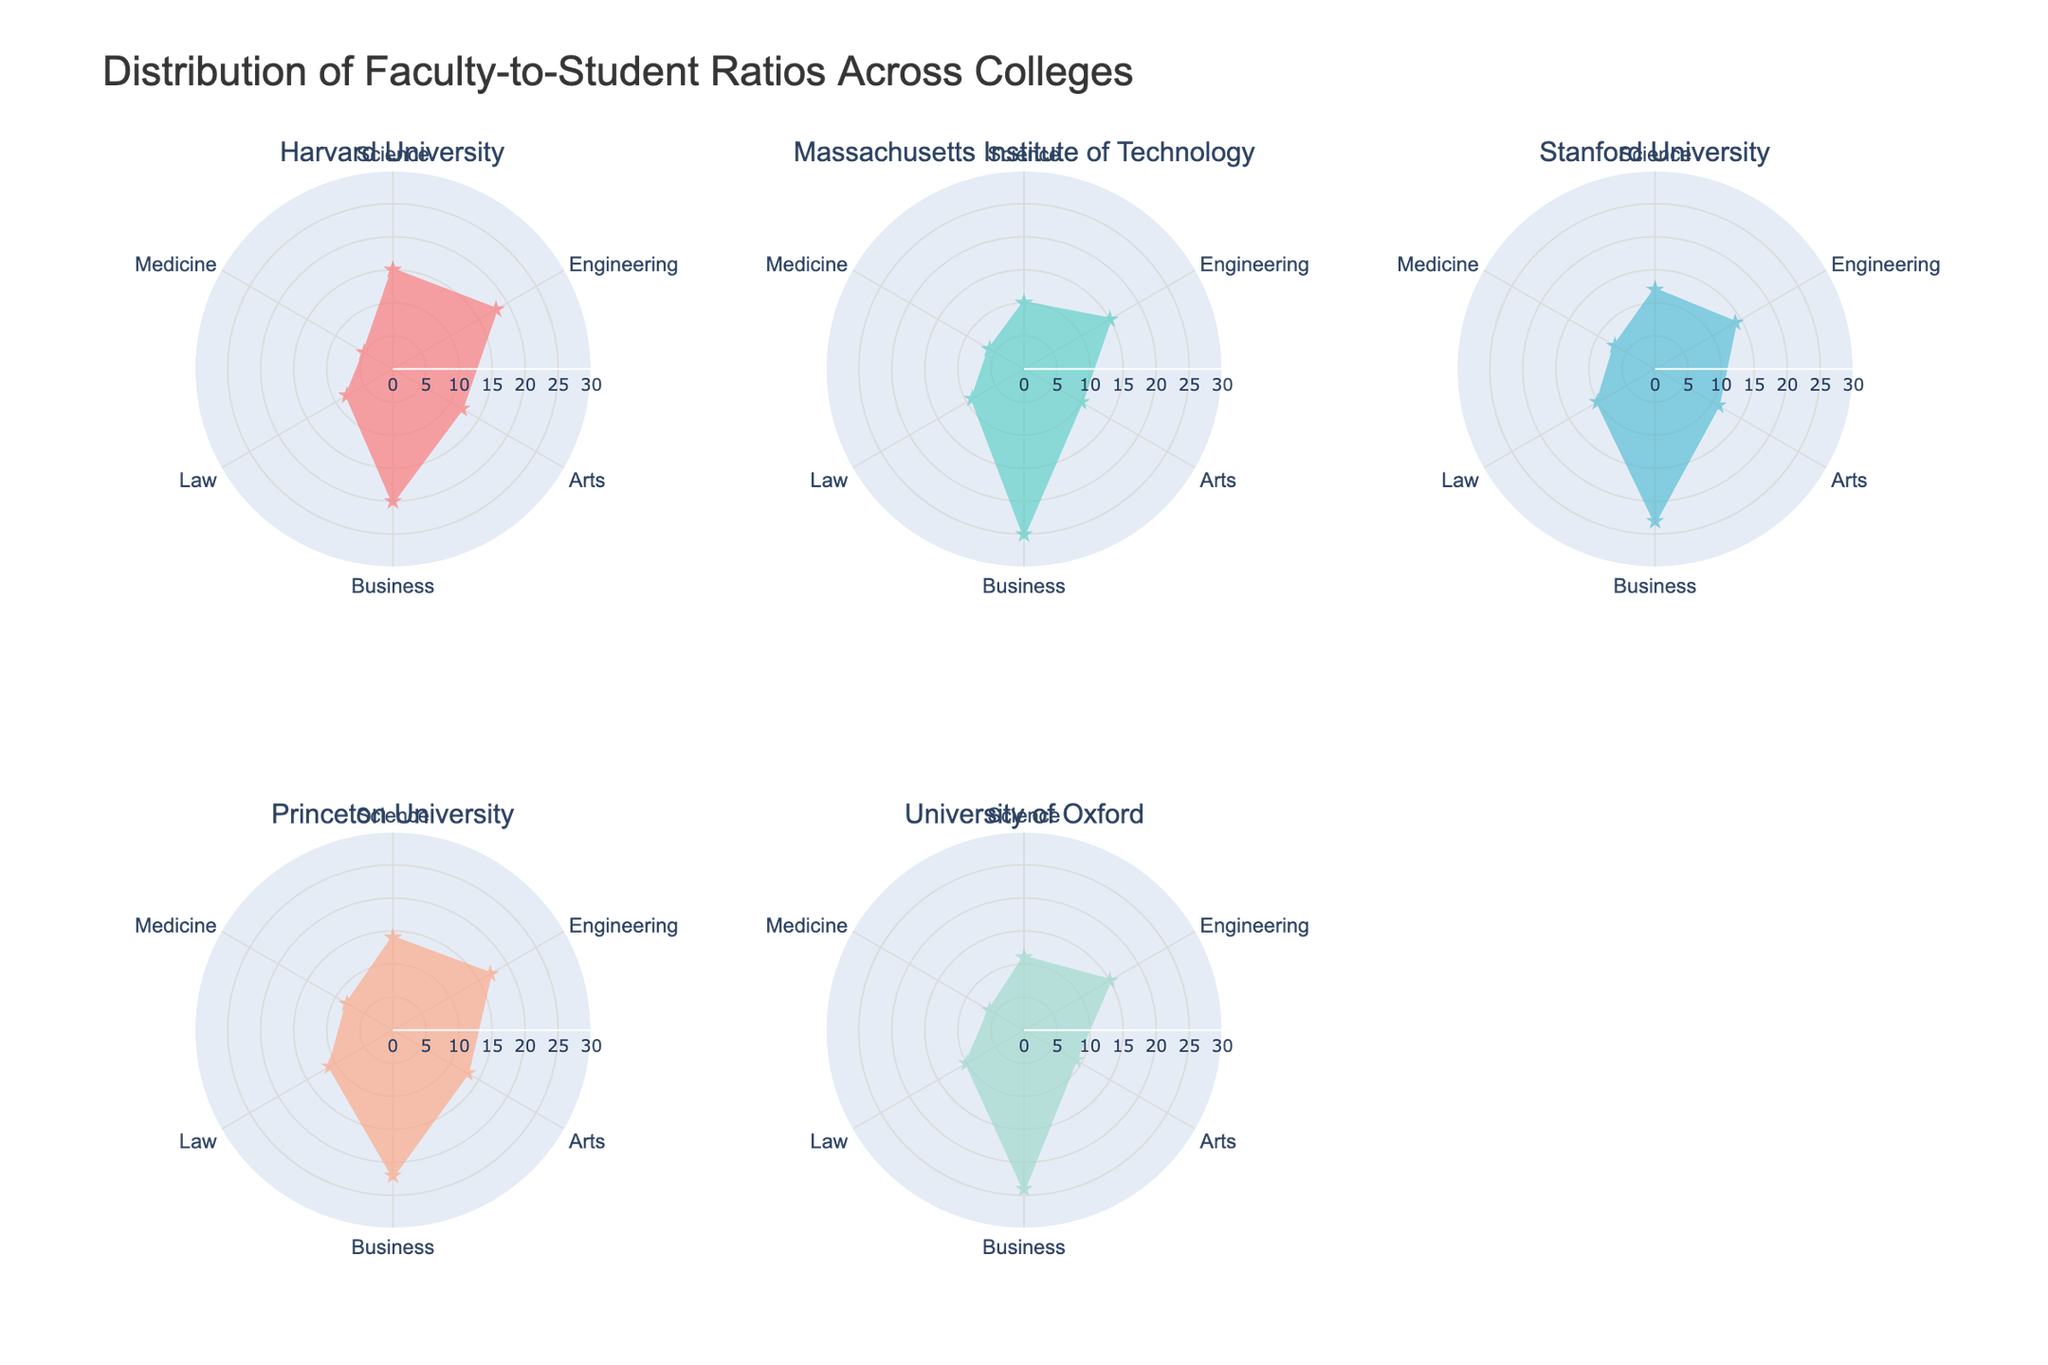What's the title of the radar chart? The title is usually placed at the top of the chart and provides a brief description of what the chart is about. Look at the top of the figure to find the title text.
Answer: Distribution of Faculty-to-Student Ratios Across Colleges Which college has the highest faculty-to-student ratio in Business? Locate the subplot that represents each college and compare the faculty-to-student ratios for the 'Business' category (look for the 'Business' label around the radar chart).
Answer: Massachusetts Institute of Technology What is the faculty-to-student ratio for Harvard University in the Medicine category? Identify the subplot for Harvard University. Then, look at the value that aligns with the 'Medicine' label on the radar chart.
Answer: 5 Which two categories have the highest and lowest faculty-to-student ratios for Princeton University? Find the Princeton University subplot. Identify the highest and lowest points along the radial axes and note the corresponding categories.
Answer: Highest: Business, Lowest: Medicine How does the faculty-to-student ratio in Engineering compare between Harvard University and University of Oxford? Locate the subplots for both Harvard University and University of Oxford. Compare their values in the Engineering category.
Answer: Harvard University: 18, University of Oxford: 15 What is the average faculty-to-student ratio across all categories for Stanford University? Add up the faculty-to-student ratios for Stanford University across Science, Engineering, Arts, Business, Law, and Medicine. Then, divide by the number of categories (6). (12 + 14 + 11 + 23 + 10 + 7) / 6 = 12.83
Answer: 12.83 Which college has the most balanced faculty-to-student ratio across all categories? Look for the subplot where the points on the radar chart are the most equidistant from the center (the points form the most circular shape).
Answer: Princeton University For University of Oxford, what is the difference in faculty-to-student ratios between the highest and lowest categories? Identify the highest and lowest faculty-to-student ratios for University of Oxford, then subtract the lowest from the highest. (Business: 24, Arts: 9. Difference: 24 - 9 = 15.)
Answer: 15 